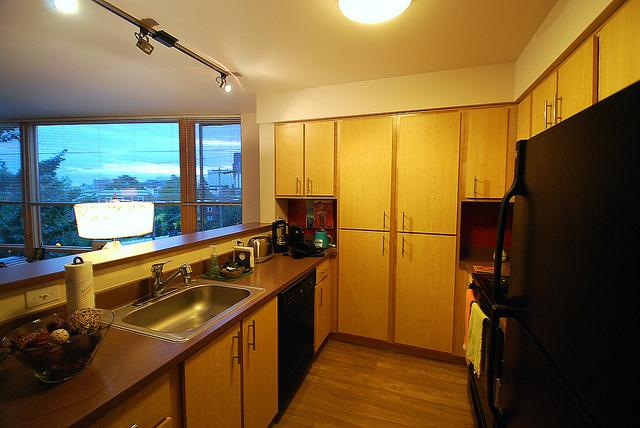What color is the light on top of the sink near the counter? white 